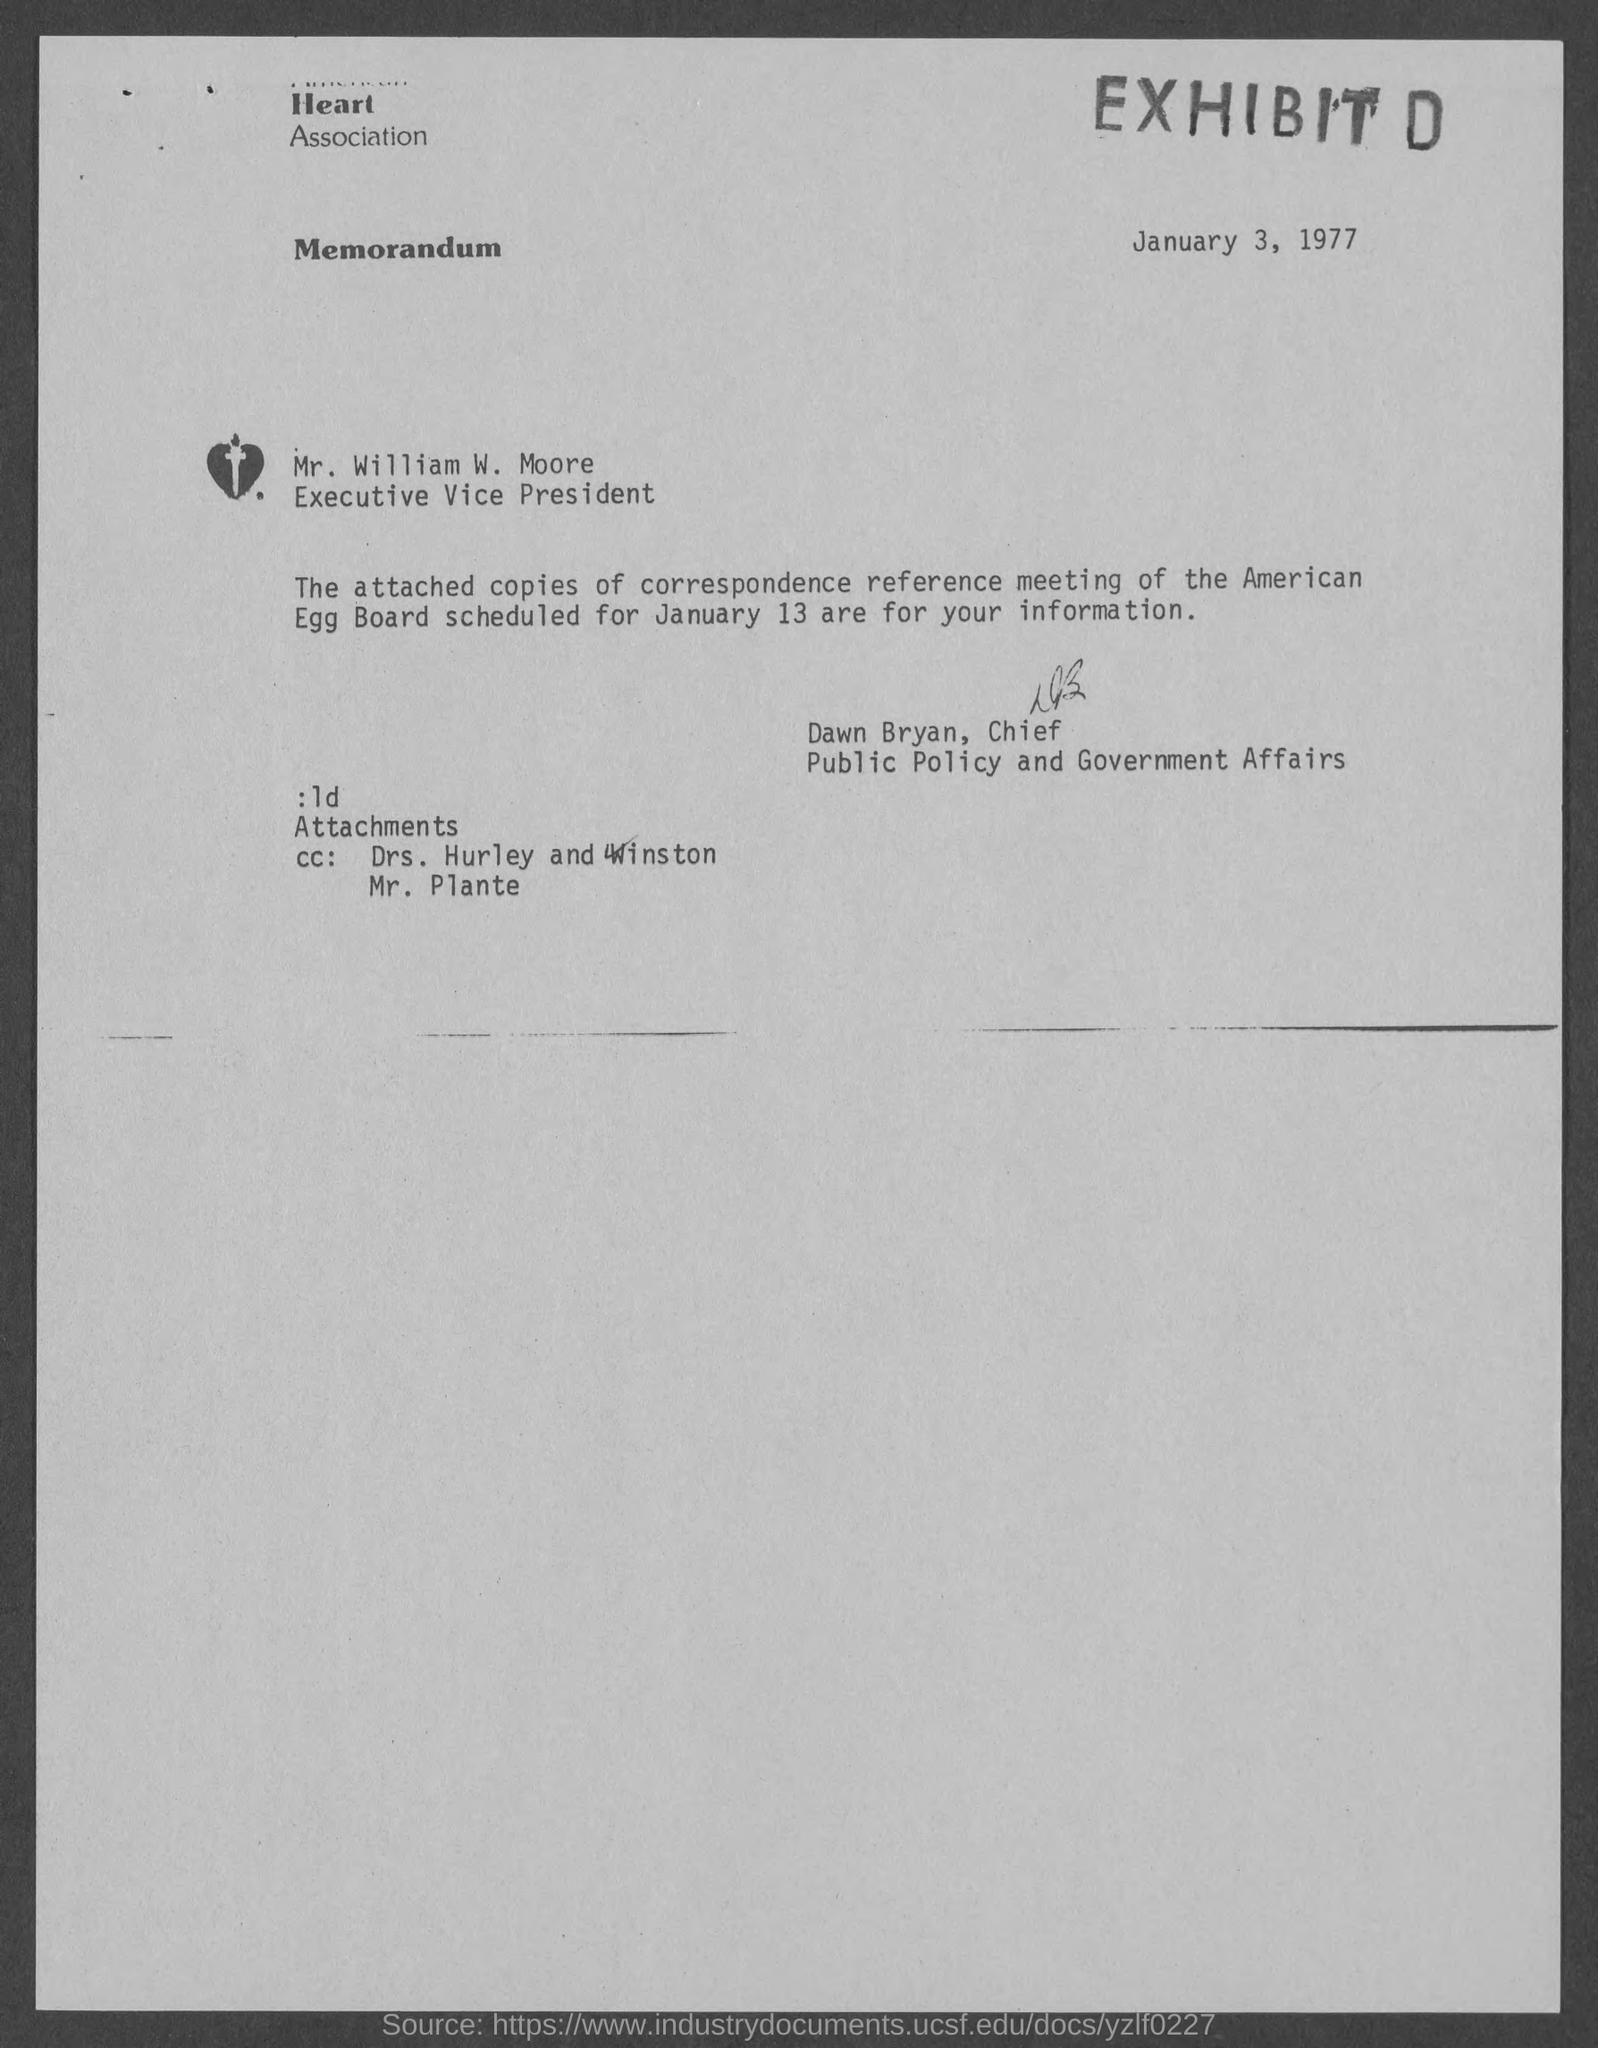Which is the date of the document?
Provide a short and direct response. January 3, 1977. When is the reference meeting scheduled?
Provide a succinct answer. January 13. Who is the sender of the letter?
Offer a very short reply. Dawn Bryan,Chief. 